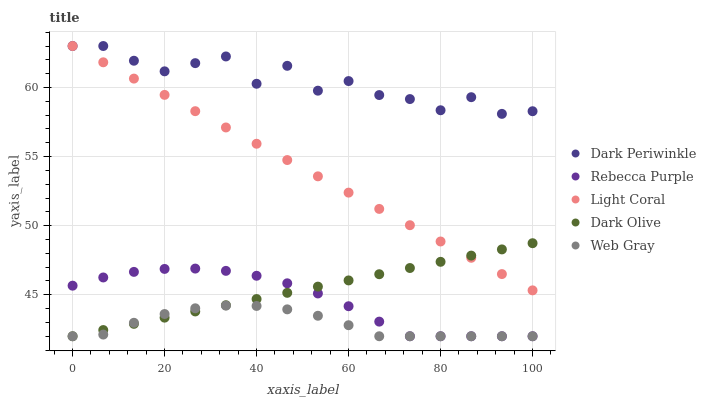Does Web Gray have the minimum area under the curve?
Answer yes or no. Yes. Does Dark Periwinkle have the maximum area under the curve?
Answer yes or no. Yes. Does Dark Olive have the minimum area under the curve?
Answer yes or no. No. Does Dark Olive have the maximum area under the curve?
Answer yes or no. No. Is Dark Olive the smoothest?
Answer yes or no. Yes. Is Dark Periwinkle the roughest?
Answer yes or no. Yes. Is Web Gray the smoothest?
Answer yes or no. No. Is Web Gray the roughest?
Answer yes or no. No. Does Dark Olive have the lowest value?
Answer yes or no. Yes. Does Dark Periwinkle have the lowest value?
Answer yes or no. No. Does Dark Periwinkle have the highest value?
Answer yes or no. Yes. Does Dark Olive have the highest value?
Answer yes or no. No. Is Web Gray less than Dark Periwinkle?
Answer yes or no. Yes. Is Dark Periwinkle greater than Rebecca Purple?
Answer yes or no. Yes. Does Light Coral intersect Dark Periwinkle?
Answer yes or no. Yes. Is Light Coral less than Dark Periwinkle?
Answer yes or no. No. Is Light Coral greater than Dark Periwinkle?
Answer yes or no. No. Does Web Gray intersect Dark Periwinkle?
Answer yes or no. No. 